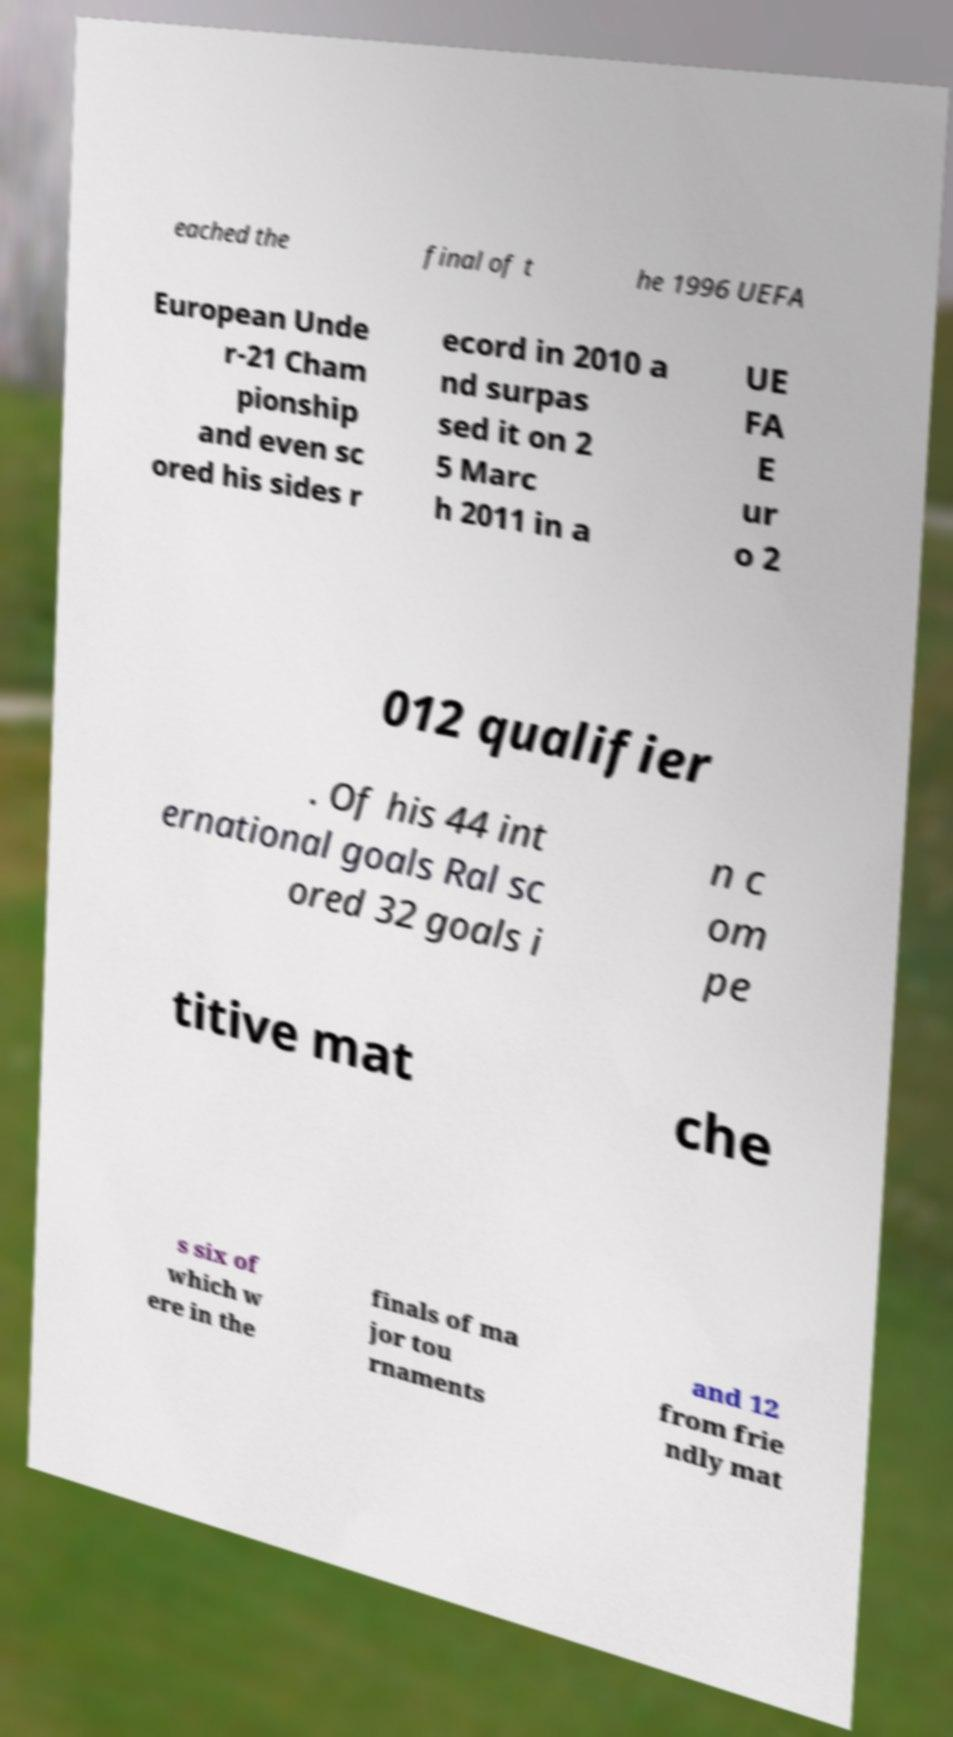Please identify and transcribe the text found in this image. eached the final of t he 1996 UEFA European Unde r-21 Cham pionship and even sc ored his sides r ecord in 2010 a nd surpas sed it on 2 5 Marc h 2011 in a UE FA E ur o 2 012 qualifier . Of his 44 int ernational goals Ral sc ored 32 goals i n c om pe titive mat che s six of which w ere in the finals of ma jor tou rnaments and 12 from frie ndly mat 